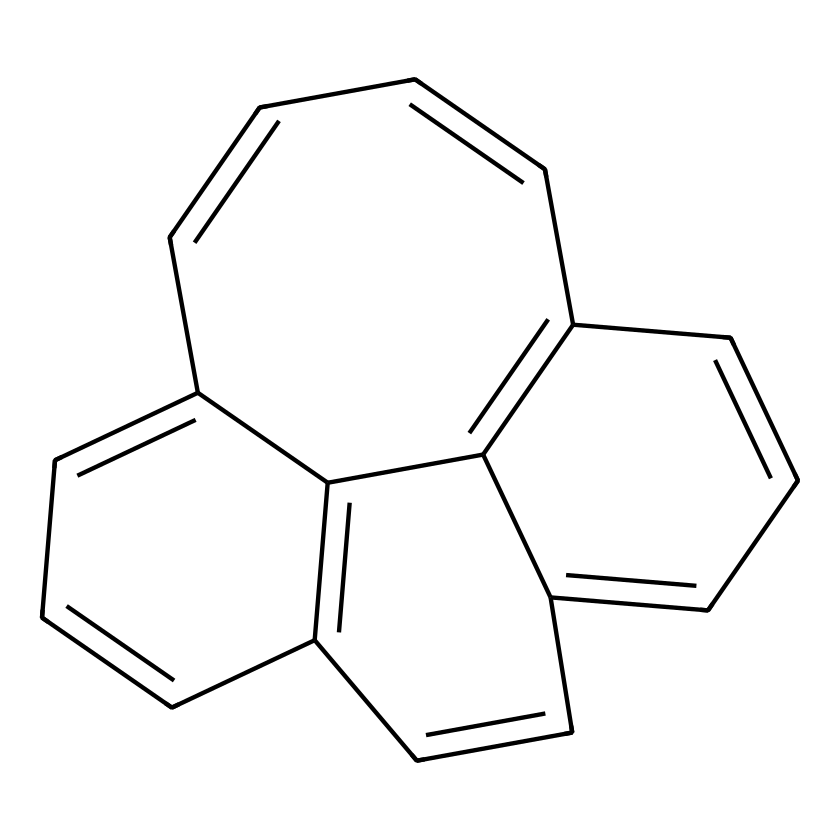What is the name of the chemical represented by this SMILES notation? The SMILES notation corresponds to a polycyclic aromatic hydrocarbon called triphenylene. This is determined by analyzing the connectivity of carbon atoms and identifying known frameworks of polycyclic structures.
Answer: triphenylene How many rings are present in this chemical structure? By inspecting the structure formed by the carbon atoms, it is evident that there are four interconnected rings. Each distinct circular structure contributes to the overall polycyclic nature.
Answer: four What is the total number of carbon atoms in this compound? Counting the carbon atoms represented in the structure yields a total of 18 carbon atoms. Each carbon element in the SMILES notation corresponds to one carbon atom in the visual structure.
Answer: eighteen How many double bonds are present in this compound? Analyzing the connections in the SMILES reveals that there are 6 double bonds throughout the rings of the structure. This is indicated by the '=' symbols between carbon atoms.
Answer: six Is this compound planar? The arrangement of the carbon atoms in the rings suggests a flat, planar structure due to the conjugated double bonds that allow for delocalization of electrons across the rings.
Answer: yes What type of isomers can this compound exhibit? Because of the presence of double bonds and the cyclic nature of the structure, this compound can exhibit geometric (cis-trans) isomerism, particularly within its ring formations.
Answer: geometric isomers 